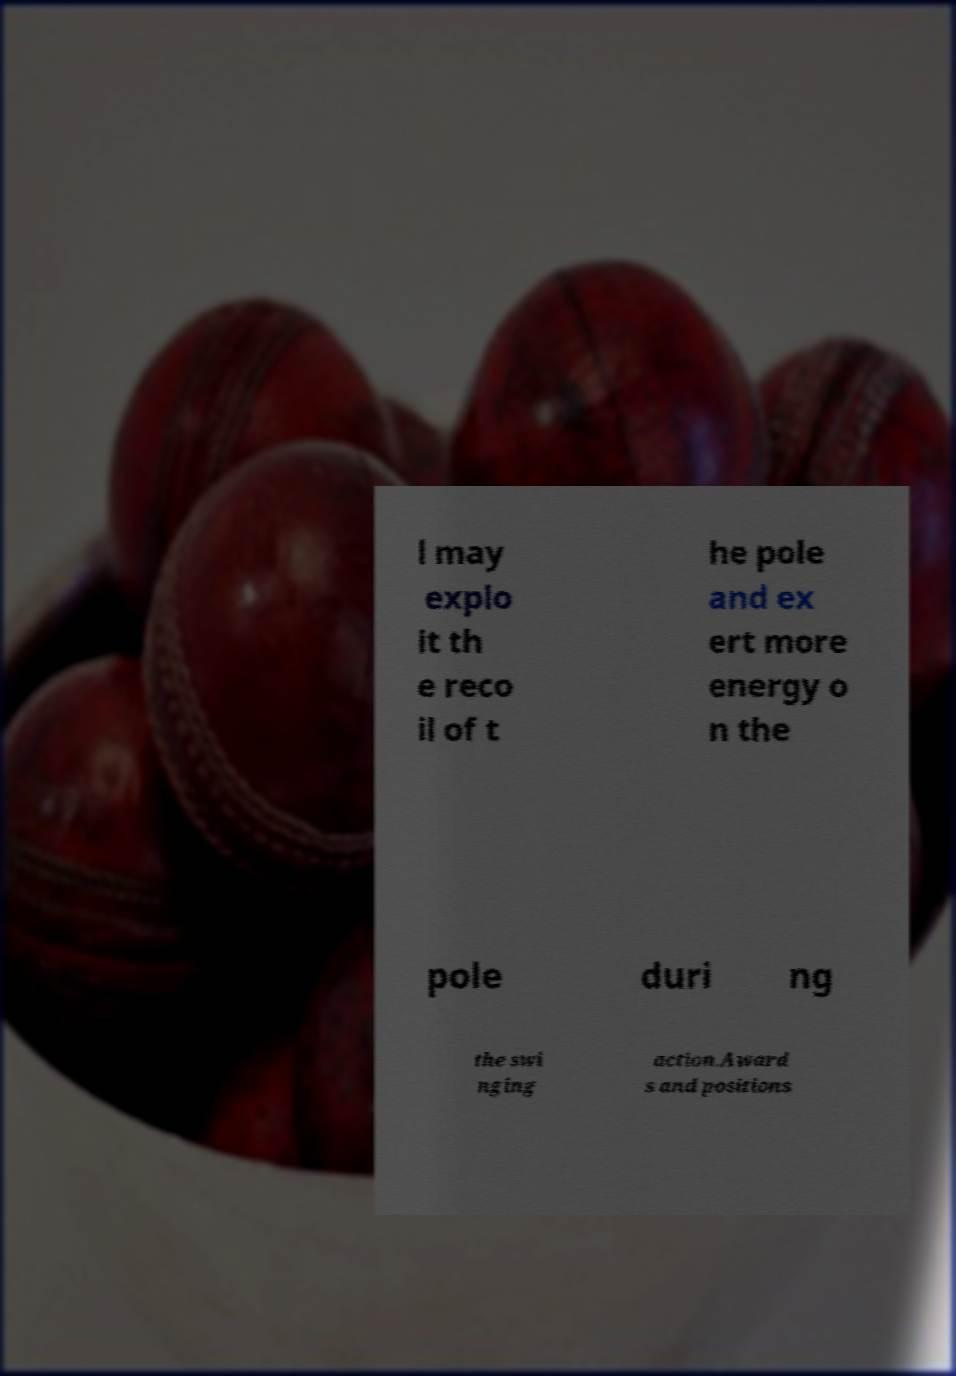Could you assist in decoding the text presented in this image and type it out clearly? l may explo it th e reco il of t he pole and ex ert more energy o n the pole duri ng the swi nging action.Award s and positions 